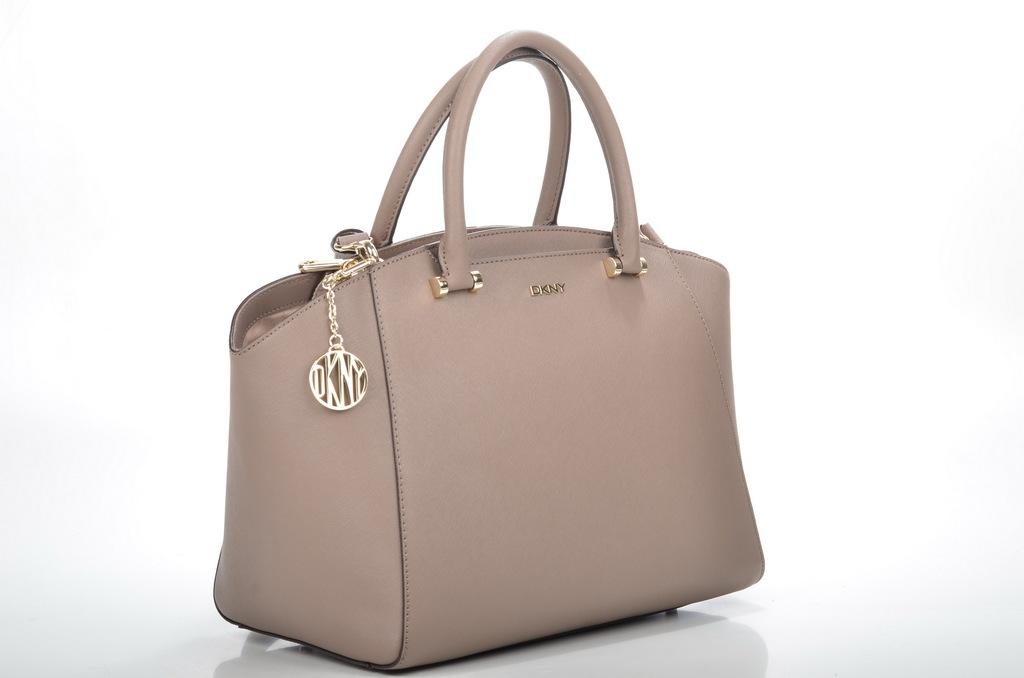What color is the background of the image? The background of the image is white. What object is present in the image? There is a bag in the image. What can be found on the bag? There is text written on the bag. Is there anything attached to the bag? Yes, there is a chain attached to the bag. What type of cheese is being offered as an answer in the image? There is no cheese or any reference to an answer in the image; it features a bag with text and a chain. 